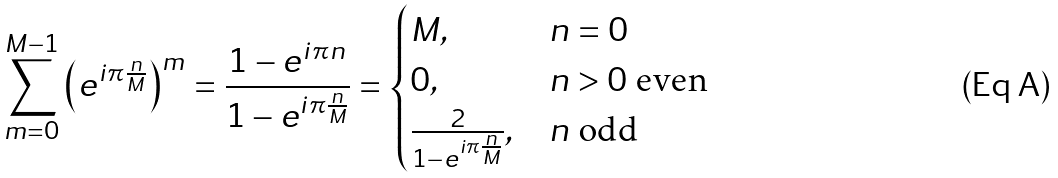<formula> <loc_0><loc_0><loc_500><loc_500>\sum ^ { M - 1 } _ { m = 0 } { \left ( e ^ { i \pi \frac { n } { M } } \right ) ^ { m } } = \frac { 1 - e ^ { i \pi n } } { 1 - e ^ { i \pi \frac { n } { M } } } = \begin{cases} M , & n = 0 \\ 0 , & n > 0 \text { even} \\ \frac { 2 } { 1 - e ^ { i \pi \frac { n } { M } } } , & n \text { odd} \end{cases}</formula> 